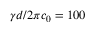Convert formula to latex. <formula><loc_0><loc_0><loc_500><loc_500>\gamma d / 2 \pi c _ { 0 } = 1 0 0</formula> 